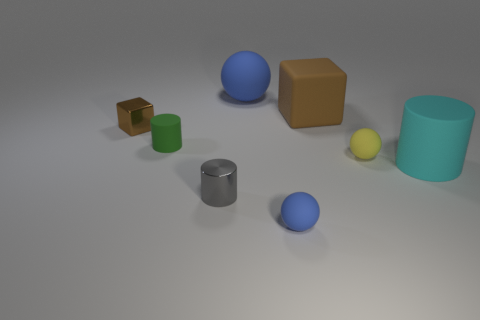Can you describe the lighting in the scene and what mood it might convey? The lighting in the image is subtle and somewhat diffuse, with no harsh shadows, creating a calm and neutral ambiance. This could imply a setting designed for clear observation without emotional bias. 